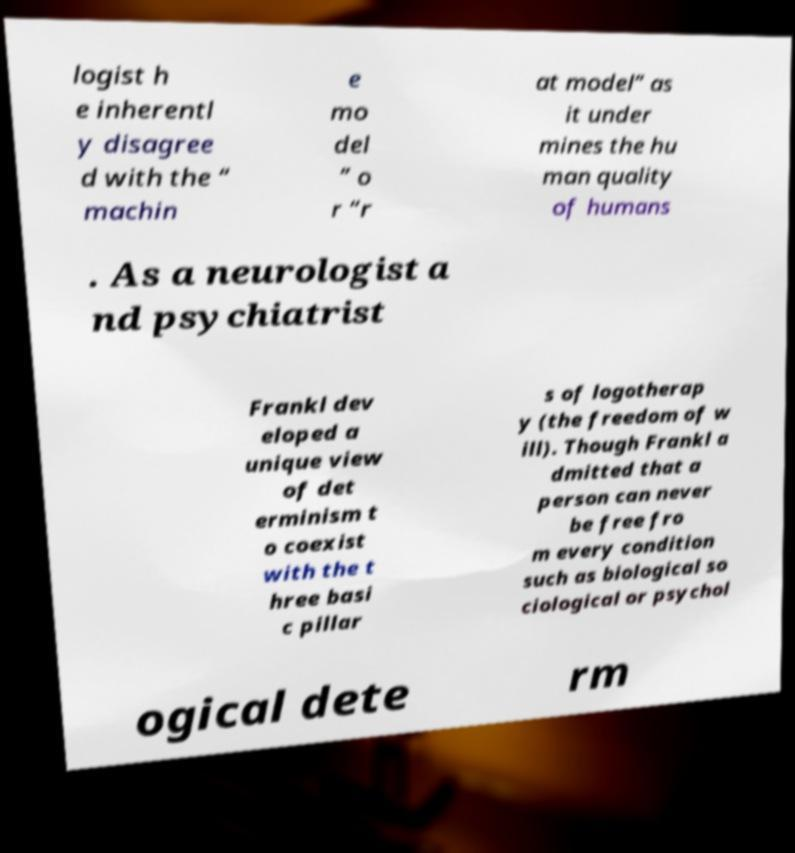Could you assist in decoding the text presented in this image and type it out clearly? logist h e inherentl y disagree d with the “ machin e mo del ” o r “r at model” as it under mines the hu man quality of humans . As a neurologist a nd psychiatrist Frankl dev eloped a unique view of det erminism t o coexist with the t hree basi c pillar s of logotherap y (the freedom of w ill). Though Frankl a dmitted that a person can never be free fro m every condition such as biological so ciological or psychol ogical dete rm 